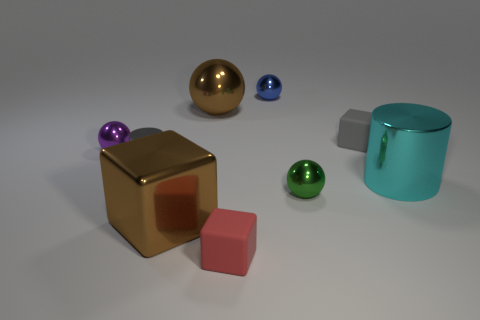Subtract 1 spheres. How many spheres are left? 3 Add 1 small cyan balls. How many objects exist? 10 Subtract all balls. How many objects are left? 5 Subtract 1 purple spheres. How many objects are left? 8 Subtract all tiny red spheres. Subtract all big cylinders. How many objects are left? 8 Add 2 big objects. How many big objects are left? 5 Add 3 matte things. How many matte things exist? 5 